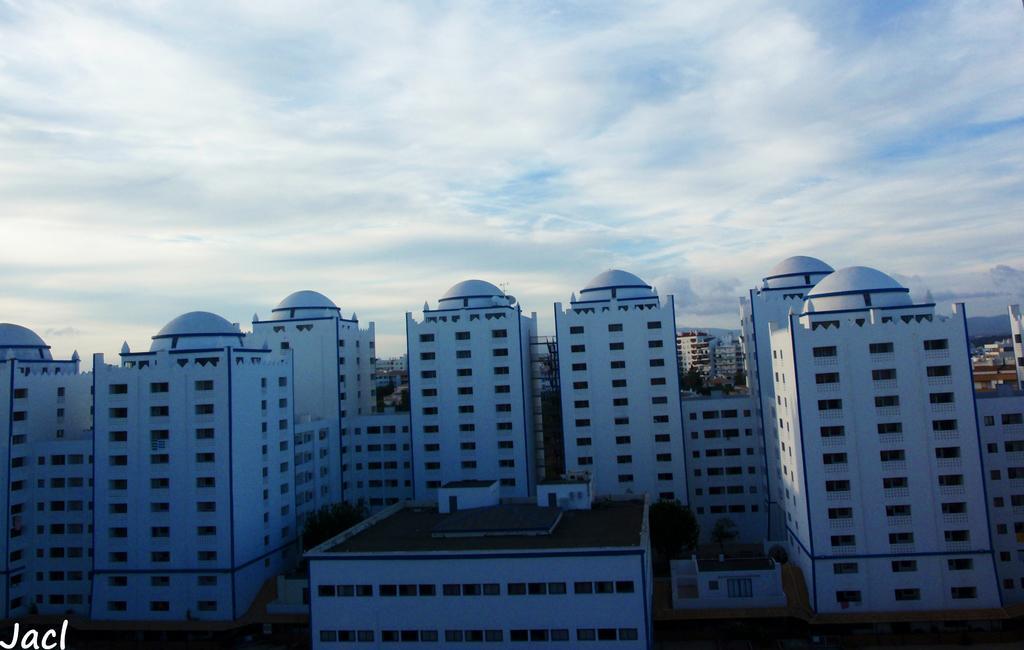Can you describe this image briefly? In this picture I can see so many buildings. 